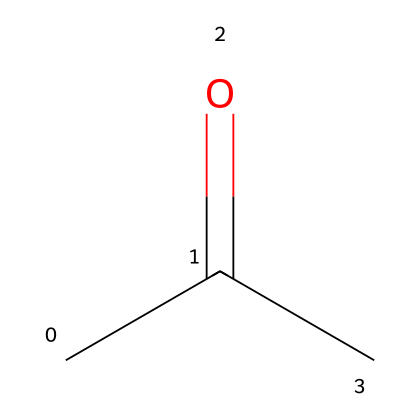What is the molecular formula of acetone? The SMILES representation "CC(=O)C" indicates that there are three carbon atoms (C), one oxygen atom (O), and six hydrogen atoms (H). Thus, the molecular formula can be deduced as C3H6O.
Answer: C3H6O How many carbon atoms are present in acetone? From the SMILES notation "CC(=O)C", we can see that there are three 'C' letters that represent three carbon atoms in the structure.
Answer: 3 What type of functional group is present in acetone? Acetone has a carbonyl group, as indicated by the "=O" in the structure, which corresponds to a ketone functional group due to its positioning between two carbon atoms.
Answer: ketone Does acetone dissociate into ions in solution? Acetone is classified as a non-electrolyte because it does not produce ions when dissolved in a solvent, such as water. This is due to its molecular composition, lacking ionizable groups.
Answer: no What is the total number of hydrogen atoms in acetone? In the representation "CC(=O)C", each carbon atom typically bonds to enough hydrogen atoms to satisfy the tetravalent nature of carbon. There are a total of six hydrogen atoms connected to the three carbon atoms in acetone.
Answer: 6 Which part of the acetone molecule is responsible for its solvent properties? The presence of the polar carbonyl group (C=O) in acetone contributes to its solvent properties, allowing it to dissolve many organic substances while not ionizing itself.
Answer: carbonyl group What is the molecular weight of acetone? The molecular weight can be calculated by adding the atomic weights of all the atoms in the molecular formula C3H6O, which totals approximately 58.08 g/mol.
Answer: 58.08 g/mol 